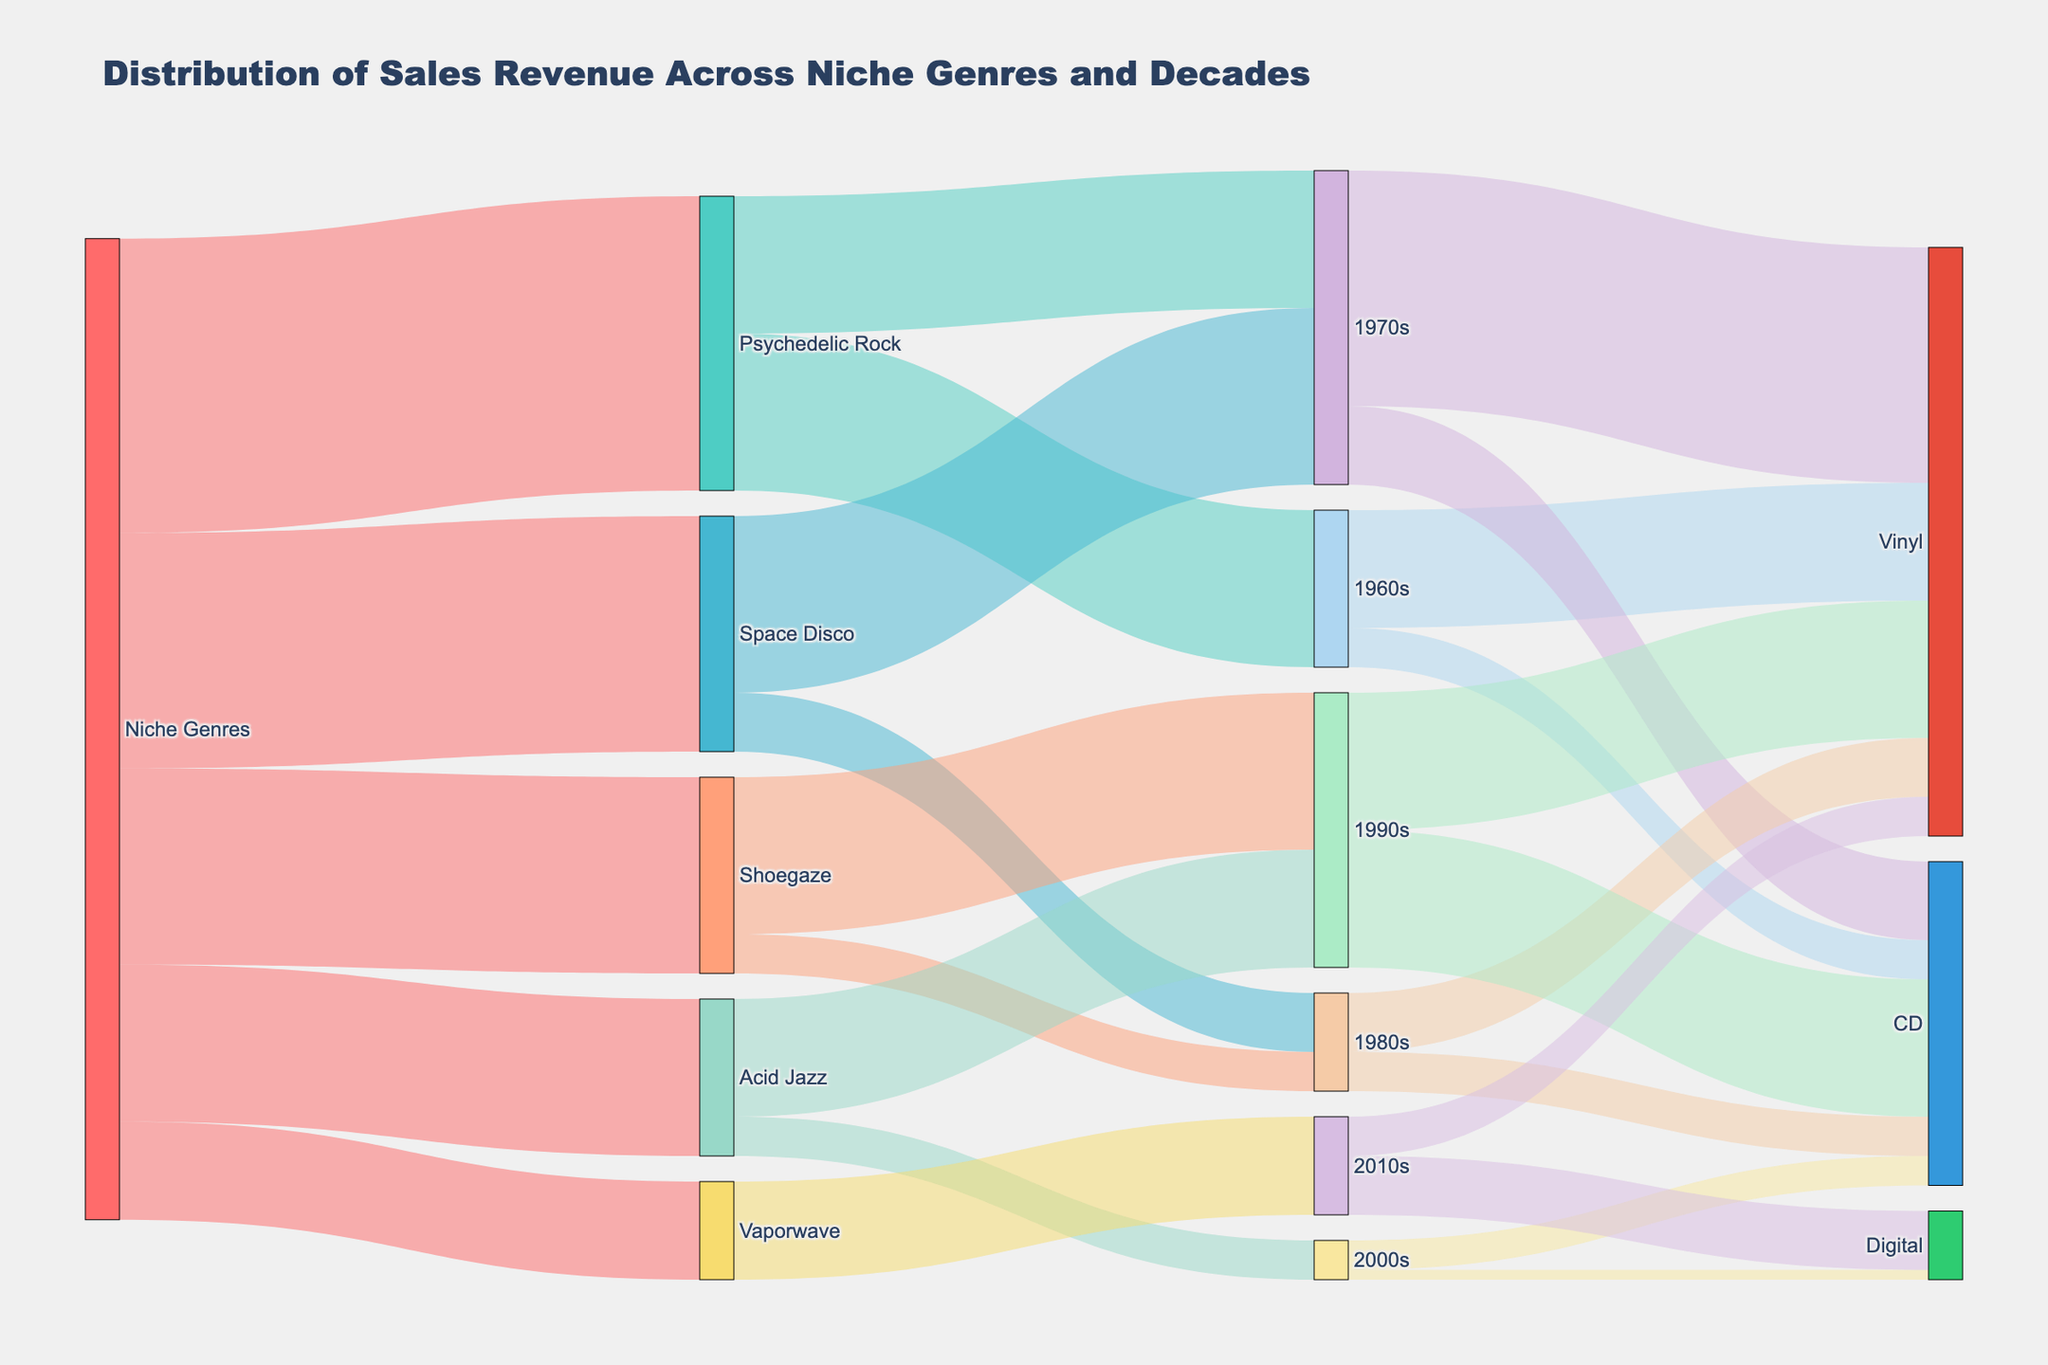What are the niche genres featured in the diagram? The diagram shows the starting point labeled 'Niche Genres' which branches out into five specific categories of niche genres. Each branch represents a different genre.
Answer: Psychedelic Rock, Space Disco, Shoegaze, Acid Jazz, Vaporwave Which decade has the highest sales revenue for Psychedelic Rock? The flow from Psychedelic Rock towards the decades indicates that it splits into the 1960s and 1970s. By observing the values associated with each split, the 1960s has a value of 8000, and the 1970s has a value of 7000.
Answer: 1960s What is the total sales revenue generated by Acid Jazz? The flow from Niche Genres to Acid Jazz shows a value of 8000. This is further divided into 6000 in the 1990s and 2000 in the 2000s. Adding these values gives 8000, which confirms the total.
Answer: 8000 What percentage of Vaporwave sales revenue comes from digital format? Vaporwave's sales revenue in the 2010s is divided between Vinyl (2000) and Digital (3000). The total for Vaporwave is 5000, so the percentage from Digital is calculated as (3000 / 5000) * 100.
Answer: 60% How do the vinyl sales compare in the 1970s versus the 1990s? By following the paths leading into the 1970s and 1990s, we see that Vinyl in the 1970s has a value of 12000 and in the 1990s has a value of 7000.
Answer: Vinyl sales are higher in the 1970s by 5000 What is the combined value of CD sales across all decades? CD sales are spread over the 1960s (2000), 1970s (4000), 1980s (2000), 1990s (7000), and 2000s (1500). Adding these up gives 2000 + 4000 + 2000 + 7000 + 1500.
Answer: 16500 Which genre shows the least sales revenue from the Niche Genres category? From Niche Genres, the values flow into each genre, and Vaporwave has the smallest value, showing a value of 5000.
Answer: Vaporwave Which decade features as the primary revenue period for Shoegaze? Shoegaze splits into the 1980s and 1990s with values of 2000 and 8000 respectively. The 1990s have the majority of the sales revenue.
Answer: 1990s 